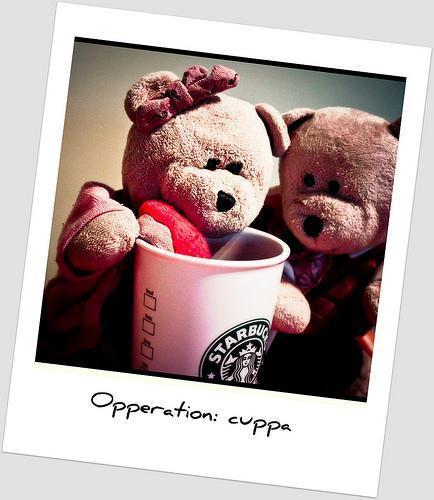How many bears are there?
Give a very brief answer. 2. 